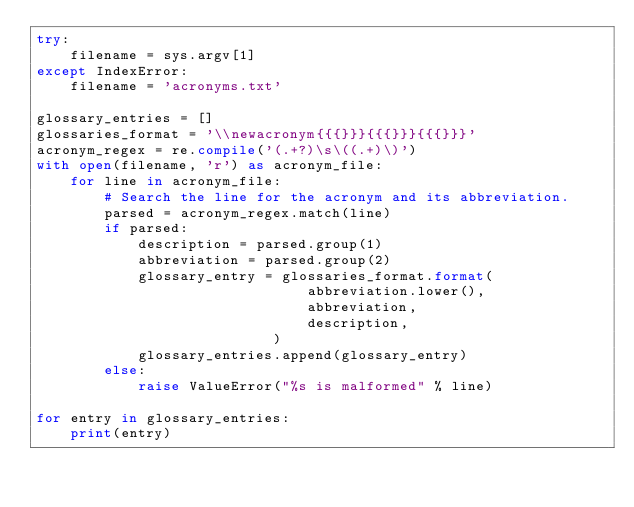Convert code to text. <code><loc_0><loc_0><loc_500><loc_500><_Python_>try:
    filename = sys.argv[1]
except IndexError:
    filename = 'acronyms.txt'

glossary_entries = []
glossaries_format = '\\newacronym{{{}}}{{{}}}{{{}}}'
acronym_regex = re.compile('(.+?)\s\((.+)\)')
with open(filename, 'r') as acronym_file:
    for line in acronym_file:
        # Search the line for the acronym and its abbreviation.
        parsed = acronym_regex.match(line)
        if parsed:
            description = parsed.group(1)
            abbreviation = parsed.group(2)
            glossary_entry = glossaries_format.format(
                                abbreviation.lower(),
                                abbreviation,
                                description,
                            )
            glossary_entries.append(glossary_entry)
        else: 
            raise ValueError("%s is malformed" % line)
        
for entry in glossary_entries:
    print(entry)
    
</code> 